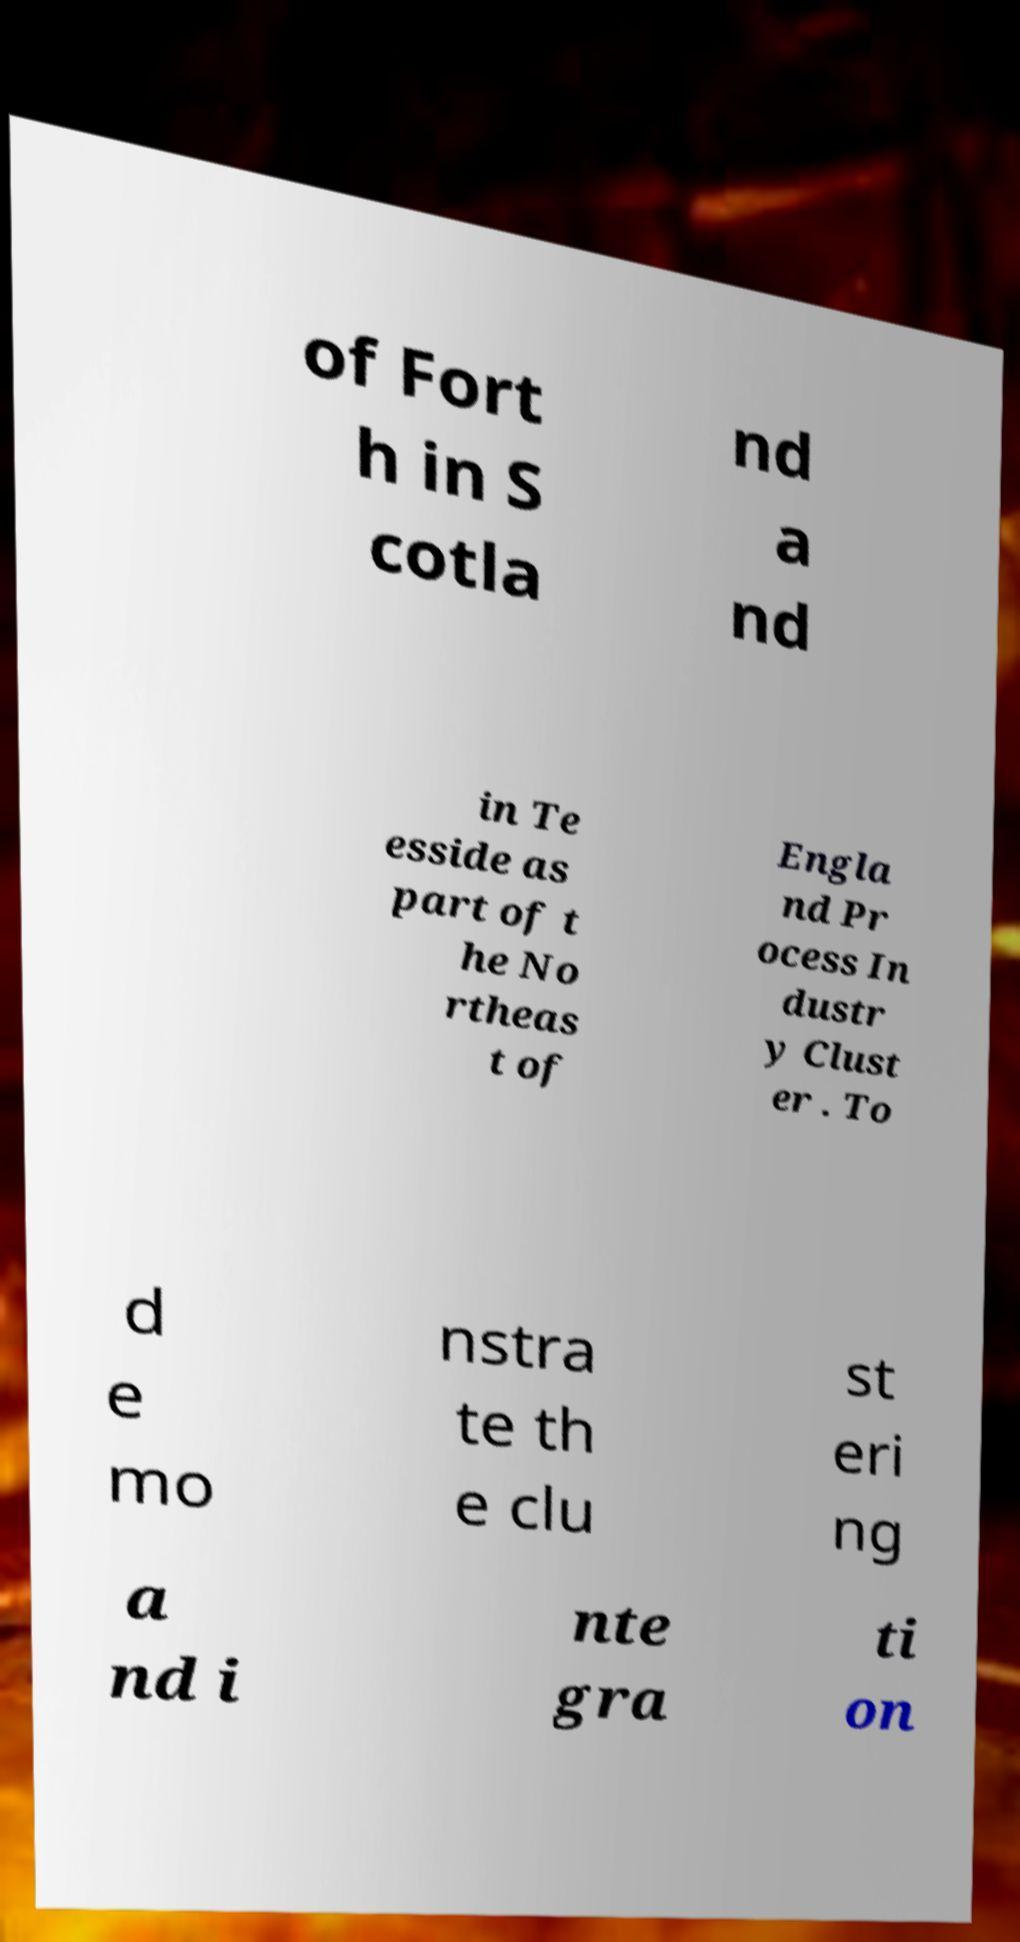Could you assist in decoding the text presented in this image and type it out clearly? of Fort h in S cotla nd a nd in Te esside as part of t he No rtheas t of Engla nd Pr ocess In dustr y Clust er . To d e mo nstra te th e clu st eri ng a nd i nte gra ti on 